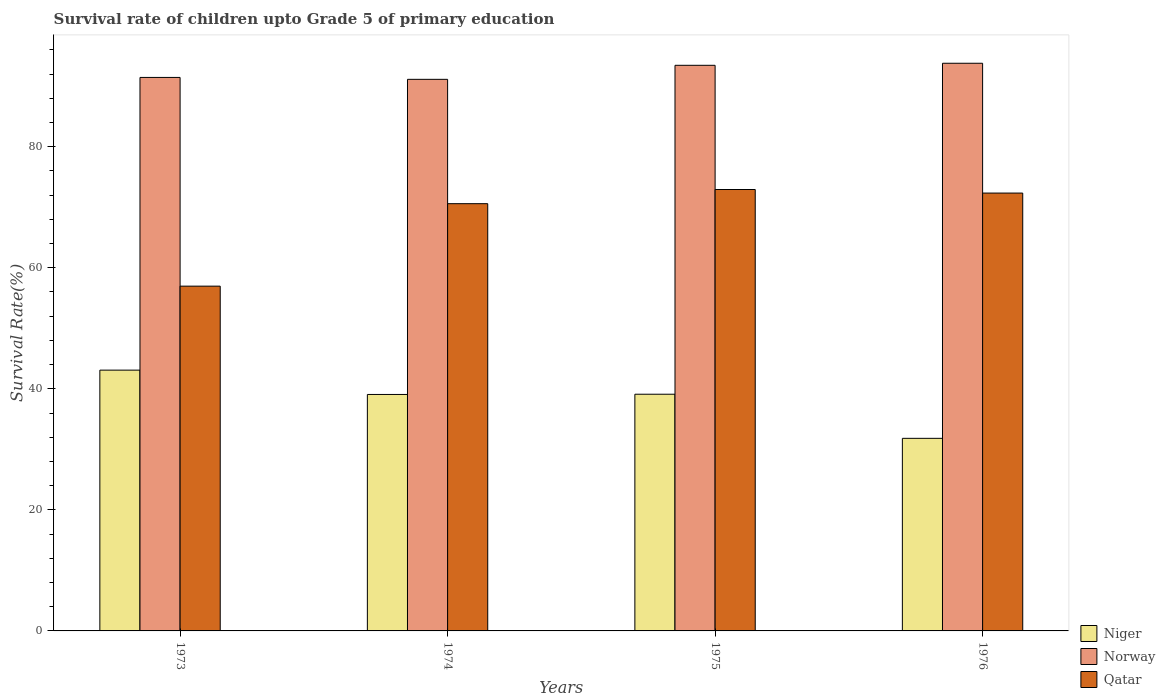How many groups of bars are there?
Your answer should be very brief. 4. Are the number of bars on each tick of the X-axis equal?
Your response must be concise. Yes. What is the label of the 2nd group of bars from the left?
Keep it short and to the point. 1974. In how many cases, is the number of bars for a given year not equal to the number of legend labels?
Your answer should be very brief. 0. What is the survival rate of children in Norway in 1973?
Provide a short and direct response. 91.43. Across all years, what is the maximum survival rate of children in Qatar?
Offer a very short reply. 72.92. Across all years, what is the minimum survival rate of children in Norway?
Ensure brevity in your answer.  91.12. In which year was the survival rate of children in Niger maximum?
Your answer should be compact. 1973. In which year was the survival rate of children in Norway minimum?
Make the answer very short. 1974. What is the total survival rate of children in Niger in the graph?
Give a very brief answer. 153.06. What is the difference between the survival rate of children in Niger in 1974 and that in 1976?
Make the answer very short. 7.25. What is the difference between the survival rate of children in Niger in 1975 and the survival rate of children in Norway in 1974?
Provide a succinct answer. -52.02. What is the average survival rate of children in Norway per year?
Your answer should be compact. 92.44. In the year 1975, what is the difference between the survival rate of children in Norway and survival rate of children in Qatar?
Offer a very short reply. 20.52. In how many years, is the survival rate of children in Norway greater than 72 %?
Provide a short and direct response. 4. What is the ratio of the survival rate of children in Norway in 1973 to that in 1974?
Give a very brief answer. 1. Is the survival rate of children in Niger in 1974 less than that in 1976?
Offer a very short reply. No. Is the difference between the survival rate of children in Norway in 1975 and 1976 greater than the difference between the survival rate of children in Qatar in 1975 and 1976?
Provide a short and direct response. No. What is the difference between the highest and the second highest survival rate of children in Qatar?
Your answer should be very brief. 0.59. What is the difference between the highest and the lowest survival rate of children in Qatar?
Make the answer very short. 15.96. In how many years, is the survival rate of children in Norway greater than the average survival rate of children in Norway taken over all years?
Give a very brief answer. 2. Is the sum of the survival rate of children in Niger in 1973 and 1976 greater than the maximum survival rate of children in Norway across all years?
Your response must be concise. No. What does the 3rd bar from the right in 1974 represents?
Your answer should be compact. Niger. Is it the case that in every year, the sum of the survival rate of children in Niger and survival rate of children in Qatar is greater than the survival rate of children in Norway?
Ensure brevity in your answer.  Yes. How many years are there in the graph?
Provide a short and direct response. 4. What is the difference between two consecutive major ticks on the Y-axis?
Give a very brief answer. 20. Are the values on the major ticks of Y-axis written in scientific E-notation?
Ensure brevity in your answer.  No. Does the graph contain any zero values?
Provide a short and direct response. No. Where does the legend appear in the graph?
Provide a short and direct response. Bottom right. How are the legend labels stacked?
Provide a short and direct response. Vertical. What is the title of the graph?
Ensure brevity in your answer.  Survival rate of children upto Grade 5 of primary education. Does "Bahamas" appear as one of the legend labels in the graph?
Provide a short and direct response. No. What is the label or title of the Y-axis?
Your response must be concise. Survival Rate(%). What is the Survival Rate(%) of Niger in 1973?
Your answer should be compact. 43.08. What is the Survival Rate(%) of Norway in 1973?
Your response must be concise. 91.43. What is the Survival Rate(%) in Qatar in 1973?
Keep it short and to the point. 56.96. What is the Survival Rate(%) of Niger in 1974?
Offer a terse response. 39.06. What is the Survival Rate(%) of Norway in 1974?
Your answer should be very brief. 91.12. What is the Survival Rate(%) in Qatar in 1974?
Provide a short and direct response. 70.58. What is the Survival Rate(%) of Niger in 1975?
Ensure brevity in your answer.  39.1. What is the Survival Rate(%) of Norway in 1975?
Offer a terse response. 93.44. What is the Survival Rate(%) in Qatar in 1975?
Provide a succinct answer. 72.92. What is the Survival Rate(%) in Niger in 1976?
Make the answer very short. 31.81. What is the Survival Rate(%) of Norway in 1976?
Provide a succinct answer. 93.78. What is the Survival Rate(%) in Qatar in 1976?
Provide a succinct answer. 72.33. Across all years, what is the maximum Survival Rate(%) in Niger?
Your response must be concise. 43.08. Across all years, what is the maximum Survival Rate(%) of Norway?
Your answer should be very brief. 93.78. Across all years, what is the maximum Survival Rate(%) of Qatar?
Provide a succinct answer. 72.92. Across all years, what is the minimum Survival Rate(%) in Niger?
Offer a very short reply. 31.81. Across all years, what is the minimum Survival Rate(%) of Norway?
Your response must be concise. 91.12. Across all years, what is the minimum Survival Rate(%) in Qatar?
Keep it short and to the point. 56.96. What is the total Survival Rate(%) of Niger in the graph?
Offer a very short reply. 153.06. What is the total Survival Rate(%) of Norway in the graph?
Provide a short and direct response. 369.77. What is the total Survival Rate(%) in Qatar in the graph?
Provide a succinct answer. 272.78. What is the difference between the Survival Rate(%) in Niger in 1973 and that in 1974?
Provide a succinct answer. 4.02. What is the difference between the Survival Rate(%) in Norway in 1973 and that in 1974?
Ensure brevity in your answer.  0.31. What is the difference between the Survival Rate(%) of Qatar in 1973 and that in 1974?
Provide a succinct answer. -13.62. What is the difference between the Survival Rate(%) of Niger in 1973 and that in 1975?
Ensure brevity in your answer.  3.98. What is the difference between the Survival Rate(%) of Norway in 1973 and that in 1975?
Make the answer very short. -2.01. What is the difference between the Survival Rate(%) of Qatar in 1973 and that in 1975?
Keep it short and to the point. -15.96. What is the difference between the Survival Rate(%) of Niger in 1973 and that in 1976?
Offer a very short reply. 11.27. What is the difference between the Survival Rate(%) of Norway in 1973 and that in 1976?
Your response must be concise. -2.34. What is the difference between the Survival Rate(%) in Qatar in 1973 and that in 1976?
Keep it short and to the point. -15.38. What is the difference between the Survival Rate(%) in Niger in 1974 and that in 1975?
Ensure brevity in your answer.  -0.04. What is the difference between the Survival Rate(%) of Norway in 1974 and that in 1975?
Provide a succinct answer. -2.32. What is the difference between the Survival Rate(%) of Qatar in 1974 and that in 1975?
Provide a succinct answer. -2.34. What is the difference between the Survival Rate(%) in Niger in 1974 and that in 1976?
Make the answer very short. 7.25. What is the difference between the Survival Rate(%) in Norway in 1974 and that in 1976?
Your answer should be very brief. -2.66. What is the difference between the Survival Rate(%) in Qatar in 1974 and that in 1976?
Your answer should be very brief. -1.75. What is the difference between the Survival Rate(%) in Niger in 1975 and that in 1976?
Ensure brevity in your answer.  7.29. What is the difference between the Survival Rate(%) of Norway in 1975 and that in 1976?
Provide a short and direct response. -0.34. What is the difference between the Survival Rate(%) of Qatar in 1975 and that in 1976?
Your answer should be compact. 0.59. What is the difference between the Survival Rate(%) of Niger in 1973 and the Survival Rate(%) of Norway in 1974?
Offer a terse response. -48.04. What is the difference between the Survival Rate(%) of Niger in 1973 and the Survival Rate(%) of Qatar in 1974?
Offer a terse response. -27.5. What is the difference between the Survival Rate(%) in Norway in 1973 and the Survival Rate(%) in Qatar in 1974?
Provide a short and direct response. 20.86. What is the difference between the Survival Rate(%) in Niger in 1973 and the Survival Rate(%) in Norway in 1975?
Offer a very short reply. -50.36. What is the difference between the Survival Rate(%) of Niger in 1973 and the Survival Rate(%) of Qatar in 1975?
Give a very brief answer. -29.84. What is the difference between the Survival Rate(%) of Norway in 1973 and the Survival Rate(%) of Qatar in 1975?
Your answer should be very brief. 18.52. What is the difference between the Survival Rate(%) in Niger in 1973 and the Survival Rate(%) in Norway in 1976?
Provide a short and direct response. -50.69. What is the difference between the Survival Rate(%) in Niger in 1973 and the Survival Rate(%) in Qatar in 1976?
Offer a very short reply. -29.25. What is the difference between the Survival Rate(%) of Norway in 1973 and the Survival Rate(%) of Qatar in 1976?
Ensure brevity in your answer.  19.1. What is the difference between the Survival Rate(%) of Niger in 1974 and the Survival Rate(%) of Norway in 1975?
Your answer should be very brief. -54.38. What is the difference between the Survival Rate(%) in Niger in 1974 and the Survival Rate(%) in Qatar in 1975?
Provide a succinct answer. -33.86. What is the difference between the Survival Rate(%) in Norway in 1974 and the Survival Rate(%) in Qatar in 1975?
Your response must be concise. 18.2. What is the difference between the Survival Rate(%) of Niger in 1974 and the Survival Rate(%) of Norway in 1976?
Your response must be concise. -54.71. What is the difference between the Survival Rate(%) in Niger in 1974 and the Survival Rate(%) in Qatar in 1976?
Keep it short and to the point. -33.27. What is the difference between the Survival Rate(%) of Norway in 1974 and the Survival Rate(%) of Qatar in 1976?
Your answer should be very brief. 18.79. What is the difference between the Survival Rate(%) of Niger in 1975 and the Survival Rate(%) of Norway in 1976?
Your answer should be very brief. -54.68. What is the difference between the Survival Rate(%) of Niger in 1975 and the Survival Rate(%) of Qatar in 1976?
Provide a short and direct response. -33.23. What is the difference between the Survival Rate(%) of Norway in 1975 and the Survival Rate(%) of Qatar in 1976?
Your answer should be very brief. 21.11. What is the average Survival Rate(%) of Niger per year?
Offer a very short reply. 38.27. What is the average Survival Rate(%) of Norway per year?
Offer a terse response. 92.44. What is the average Survival Rate(%) in Qatar per year?
Offer a terse response. 68.2. In the year 1973, what is the difference between the Survival Rate(%) in Niger and Survival Rate(%) in Norway?
Give a very brief answer. -48.35. In the year 1973, what is the difference between the Survival Rate(%) in Niger and Survival Rate(%) in Qatar?
Provide a short and direct response. -13.87. In the year 1973, what is the difference between the Survival Rate(%) of Norway and Survival Rate(%) of Qatar?
Your response must be concise. 34.48. In the year 1974, what is the difference between the Survival Rate(%) of Niger and Survival Rate(%) of Norway?
Your response must be concise. -52.06. In the year 1974, what is the difference between the Survival Rate(%) of Niger and Survival Rate(%) of Qatar?
Make the answer very short. -31.52. In the year 1974, what is the difference between the Survival Rate(%) of Norway and Survival Rate(%) of Qatar?
Provide a succinct answer. 20.54. In the year 1975, what is the difference between the Survival Rate(%) in Niger and Survival Rate(%) in Norway?
Provide a short and direct response. -54.34. In the year 1975, what is the difference between the Survival Rate(%) of Niger and Survival Rate(%) of Qatar?
Your answer should be very brief. -33.82. In the year 1975, what is the difference between the Survival Rate(%) of Norway and Survival Rate(%) of Qatar?
Give a very brief answer. 20.52. In the year 1976, what is the difference between the Survival Rate(%) of Niger and Survival Rate(%) of Norway?
Offer a very short reply. -61.96. In the year 1976, what is the difference between the Survival Rate(%) of Niger and Survival Rate(%) of Qatar?
Give a very brief answer. -40.52. In the year 1976, what is the difference between the Survival Rate(%) in Norway and Survival Rate(%) in Qatar?
Provide a succinct answer. 21.44. What is the ratio of the Survival Rate(%) of Niger in 1973 to that in 1974?
Make the answer very short. 1.1. What is the ratio of the Survival Rate(%) in Norway in 1973 to that in 1974?
Offer a very short reply. 1. What is the ratio of the Survival Rate(%) of Qatar in 1973 to that in 1974?
Your response must be concise. 0.81. What is the ratio of the Survival Rate(%) in Niger in 1973 to that in 1975?
Ensure brevity in your answer.  1.1. What is the ratio of the Survival Rate(%) of Norway in 1973 to that in 1975?
Offer a very short reply. 0.98. What is the ratio of the Survival Rate(%) in Qatar in 1973 to that in 1975?
Offer a very short reply. 0.78. What is the ratio of the Survival Rate(%) in Niger in 1973 to that in 1976?
Provide a succinct answer. 1.35. What is the ratio of the Survival Rate(%) in Qatar in 1973 to that in 1976?
Provide a succinct answer. 0.79. What is the ratio of the Survival Rate(%) in Niger in 1974 to that in 1975?
Your response must be concise. 1. What is the ratio of the Survival Rate(%) in Norway in 1974 to that in 1975?
Your answer should be very brief. 0.98. What is the ratio of the Survival Rate(%) of Qatar in 1974 to that in 1975?
Your answer should be very brief. 0.97. What is the ratio of the Survival Rate(%) of Niger in 1974 to that in 1976?
Offer a terse response. 1.23. What is the ratio of the Survival Rate(%) of Norway in 1974 to that in 1976?
Ensure brevity in your answer.  0.97. What is the ratio of the Survival Rate(%) of Qatar in 1974 to that in 1976?
Offer a very short reply. 0.98. What is the ratio of the Survival Rate(%) in Niger in 1975 to that in 1976?
Ensure brevity in your answer.  1.23. What is the difference between the highest and the second highest Survival Rate(%) of Niger?
Make the answer very short. 3.98. What is the difference between the highest and the second highest Survival Rate(%) of Norway?
Offer a terse response. 0.34. What is the difference between the highest and the second highest Survival Rate(%) of Qatar?
Provide a short and direct response. 0.59. What is the difference between the highest and the lowest Survival Rate(%) in Niger?
Keep it short and to the point. 11.27. What is the difference between the highest and the lowest Survival Rate(%) in Norway?
Keep it short and to the point. 2.66. What is the difference between the highest and the lowest Survival Rate(%) of Qatar?
Provide a succinct answer. 15.96. 